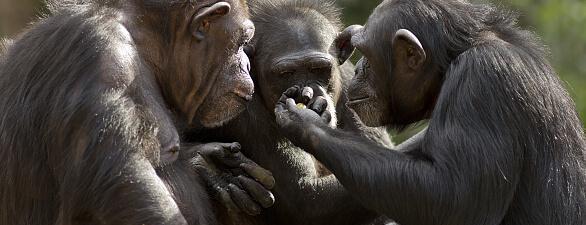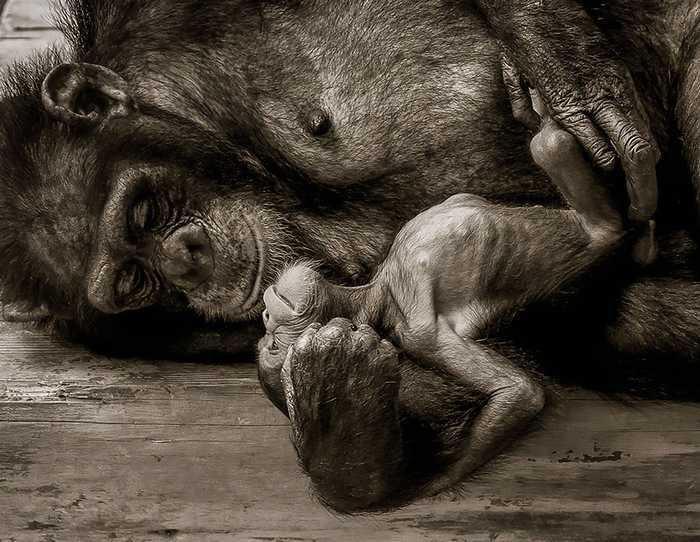The first image is the image on the left, the second image is the image on the right. Analyze the images presented: Is the assertion "Six chimps can be seen" valid? Answer yes or no. No. The first image is the image on the left, the second image is the image on the right. Assess this claim about the two images: "One image includes an adult chimp lying on its side face-to-face with a baby chimp and holding the baby chimp's leg.". Correct or not? Answer yes or no. Yes. 